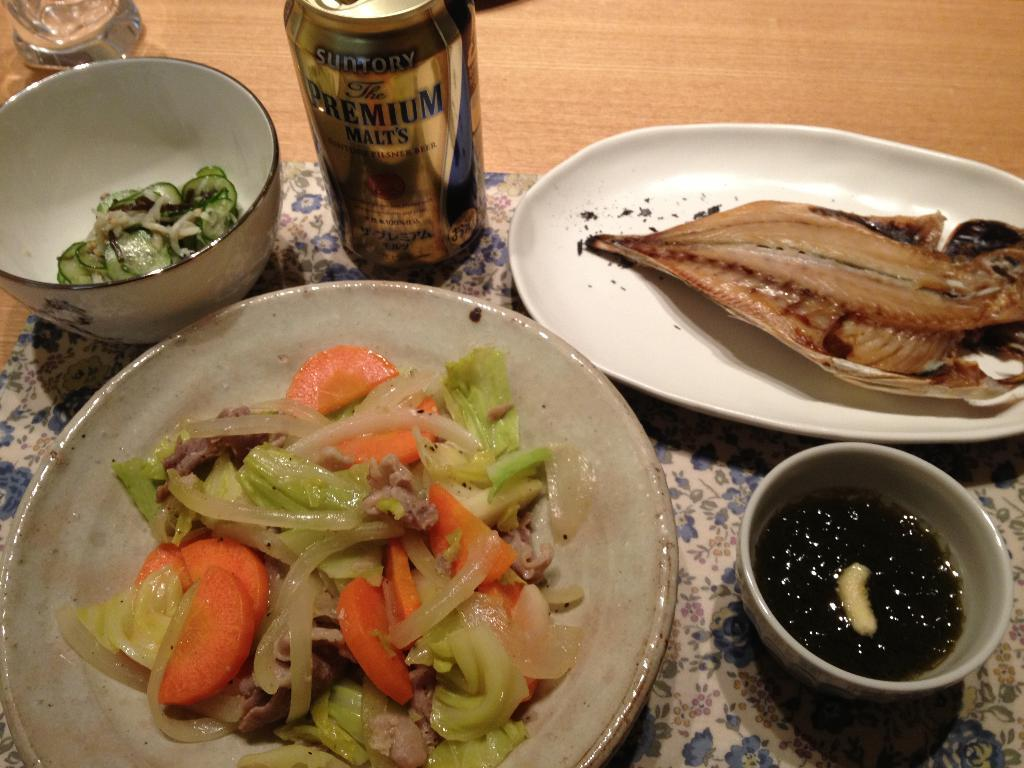What types of containers are used for the food items in the image? There are plates and bowls used for the food items in the image. What other object can be seen in the image? There is a tin can in the image. What is the surface on which the food items and tin can are placed? The food items and tin can are placed on a wooden surface in the image. What type of club is visible in the image? There is no club present in the image. What type of produce can be seen in the image? There is no produce visible in the image. 